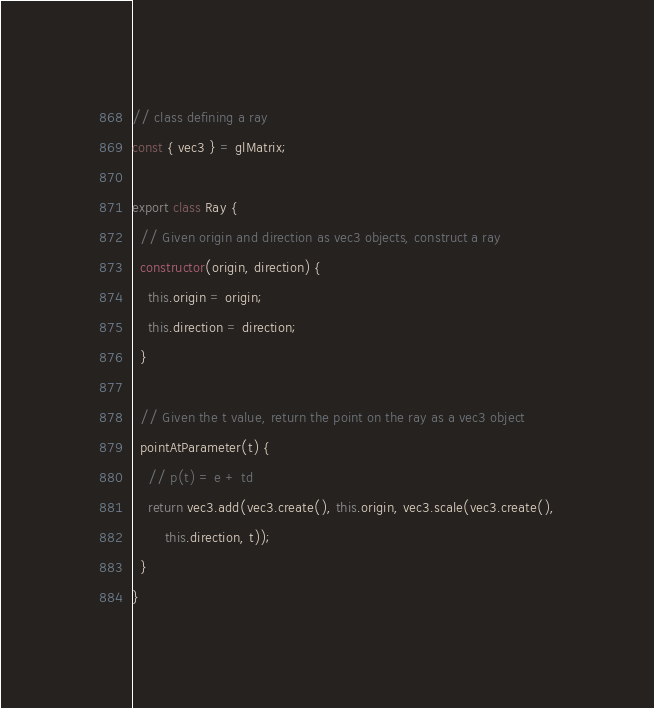<code> <loc_0><loc_0><loc_500><loc_500><_JavaScript_>// class defining a ray
const { vec3 } = glMatrix;

export class Ray {
  // Given origin and direction as vec3 objects, construct a ray
  constructor(origin, direction) {
    this.origin = origin;
    this.direction = direction;
  }

  // Given the t value, return the point on the ray as a vec3 object
  pointAtParameter(t) {
    // p(t) = e + td
    return vec3.add(vec3.create(), this.origin, vec3.scale(vec3.create(),
        this.direction, t));
  }
}
</code> 